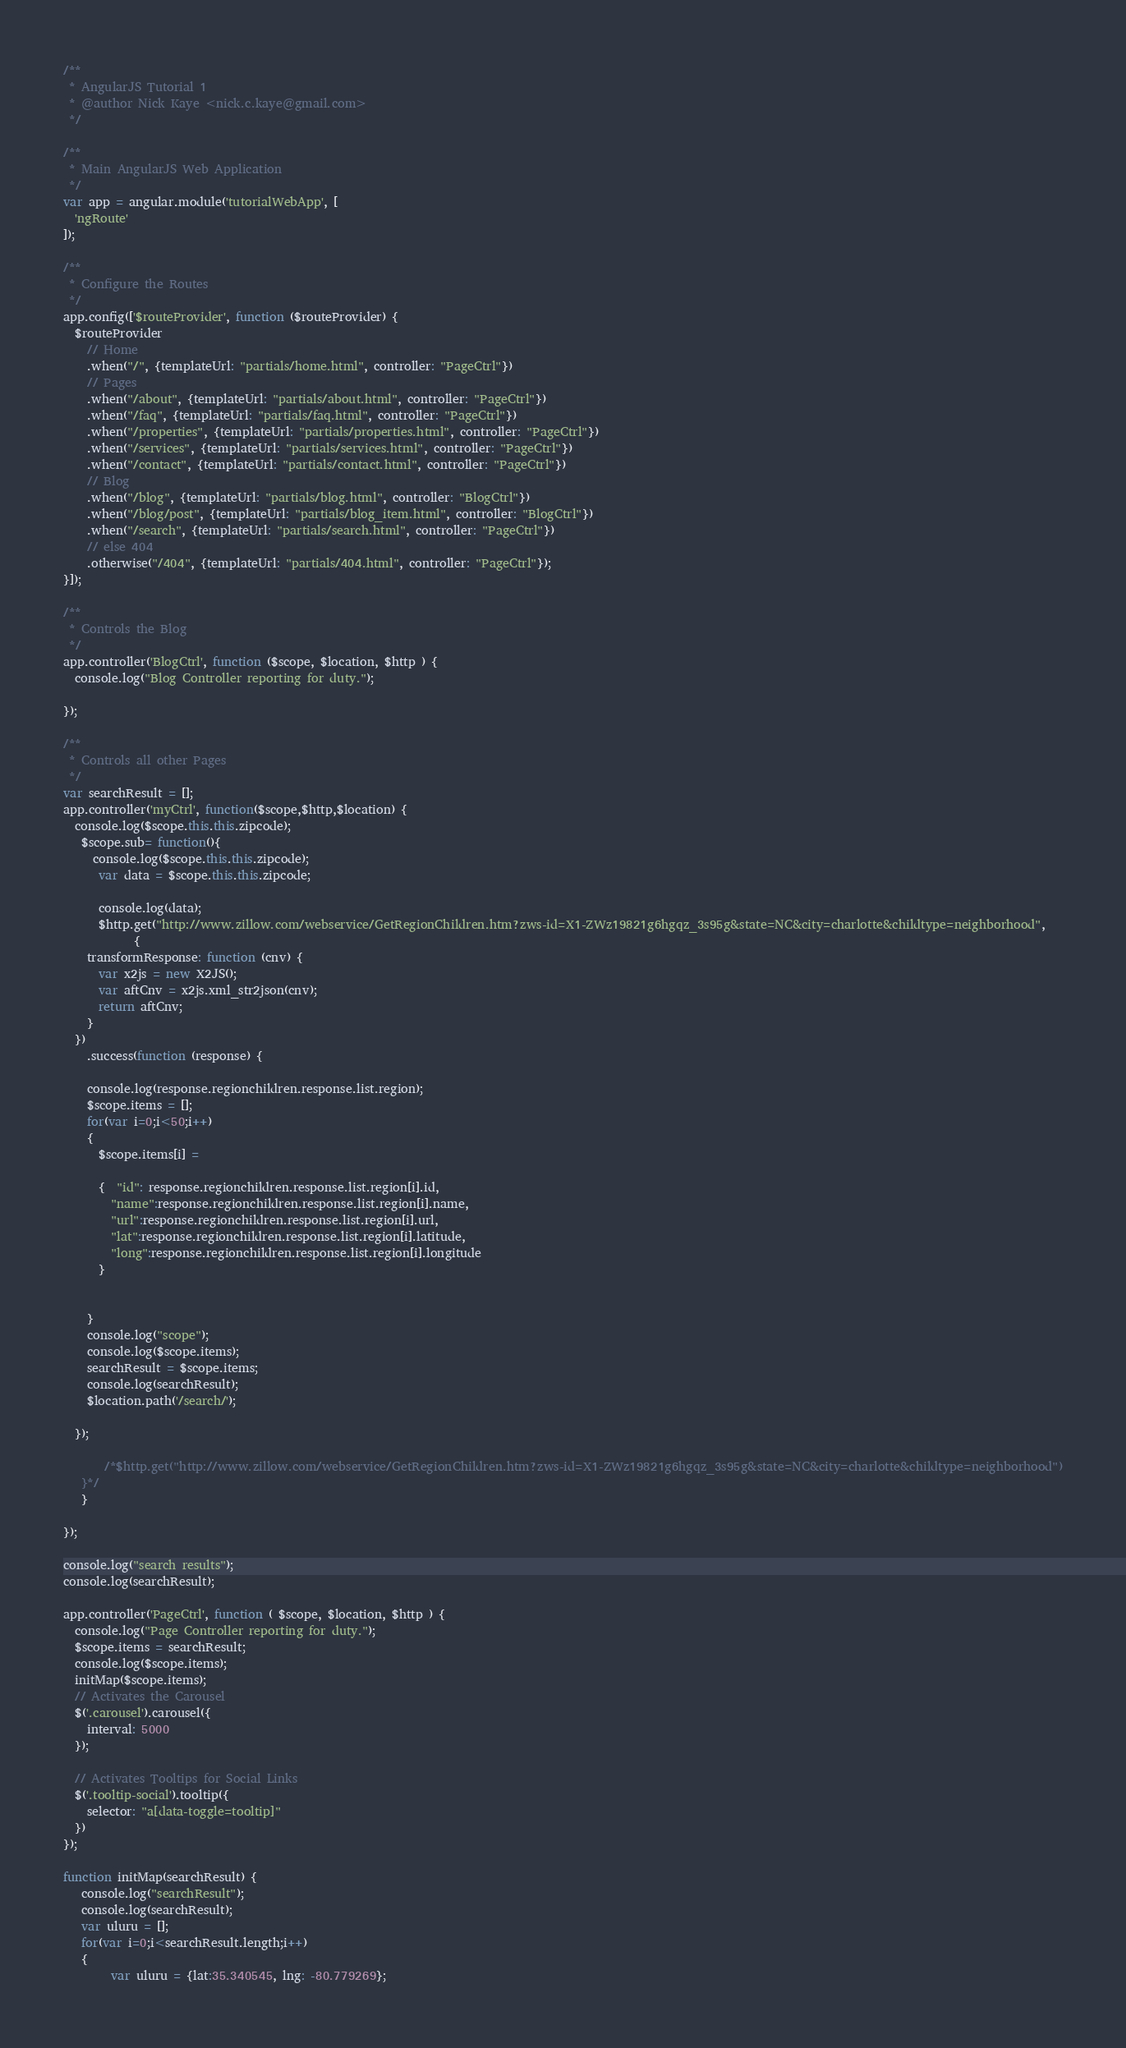Convert code to text. <code><loc_0><loc_0><loc_500><loc_500><_JavaScript_>/**
 * AngularJS Tutorial 1
 * @author Nick Kaye <nick.c.kaye@gmail.com>
 */

/**
 * Main AngularJS Web Application
 */
var app = angular.module('tutorialWebApp', [
  'ngRoute'
]);

/**
 * Configure the Routes
 */
app.config(['$routeProvider', function ($routeProvider) {
  $routeProvider
    // Home
    .when("/", {templateUrl: "partials/home.html", controller: "PageCtrl"})
    // Pages
    .when("/about", {templateUrl: "partials/about.html", controller: "PageCtrl"})
    .when("/faq", {templateUrl: "partials/faq.html", controller: "PageCtrl"})
    .when("/properties", {templateUrl: "partials/properties.html", controller: "PageCtrl"})
    .when("/services", {templateUrl: "partials/services.html", controller: "PageCtrl"})
    .when("/contact", {templateUrl: "partials/contact.html", controller: "PageCtrl"})
    // Blog
    .when("/blog", {templateUrl: "partials/blog.html", controller: "BlogCtrl"})
    .when("/blog/post", {templateUrl: "partials/blog_item.html", controller: "BlogCtrl"})
    .when("/search", {templateUrl: "partials/search.html", controller: "PageCtrl"})
    // else 404
    .otherwise("/404", {templateUrl: "partials/404.html", controller: "PageCtrl"});
}]);

/**
 * Controls the Blog
 */
app.controller('BlogCtrl', function ($scope, $location, $http ) {
  console.log("Blog Controller reporting for duty.");
  
});

/**
 * Controls all other Pages
 */
var searchResult = [];
app.controller('myCtrl', function($scope,$http,$location) {
  console.log($scope.this.this.zipcode);
   $scope.sub= function(){
     console.log($scope.this.this.zipcode);
      var data = $scope.this.this.zipcode;

      console.log(data);
      $http.get("http://www.zillow.com/webservice/GetRegionChildren.htm?zws-id=X1-ZWz19821g6hgqz_3s95g&state=NC&city=charlotte&childtype=neighborhood",
            {
    transformResponse: function (cnv) {
      var x2js = new X2JS();
      var aftCnv = x2js.xml_str2json(cnv);
      return aftCnv;
    }
  })
    .success(function (response) {
    
    console.log(response.regionchildren.response.list.region);
    $scope.items = [];
    for(var i=0;i<50;i++)
    {
      $scope.items[i] =

      {  "id": response.regionchildren.response.list.region[i].id,
        "name":response.regionchildren.response.list.region[i].name,
        "url":response.regionchildren.response.list.region[i].url,
        "lat":response.regionchildren.response.list.region[i].latitude,
        "long":response.regionchildren.response.list.region[i].longitude
      }

      
    }
    console.log("scope");
    console.log($scope.items);
    searchResult = $scope.items;
    console.log(searchResult);
    $location.path('/search/');

  });

       /*$http.get("http://www.zillow.com/webservice/GetRegionChildren.htm?zws-id=X1-ZWz19821g6hgqz_3s95g&state=NC&city=charlotte&childtype=neighborhood")
   }*/
   }
      
});

console.log("search results");
console.log(searchResult);

app.controller('PageCtrl', function ( $scope, $location, $http ) {
  console.log("Page Controller reporting for duty."); 
  $scope.items = searchResult;  
  console.log($scope.items);
  initMap($scope.items);
  // Activates the Carousel
  $('.carousel').carousel({
    interval: 5000
  });

  // Activates Tooltips for Social Links
  $('.tooltip-social').tooltip({
    selector: "a[data-toggle=tooltip]"
  })
});

function initMap(searchResult) {
   console.log("searchResult");
   console.log(searchResult);
   var uluru = [];
   for(var i=0;i<searchResult.length;i++)
   {
        var uluru = {lat:35.340545, lng: -80.779269};</code> 